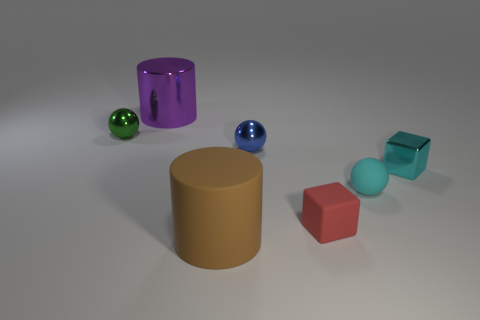How many cylinders are purple metal objects or large objects?
Provide a succinct answer. 2. There is a small rubber thing behind the tiny red rubber cube that is on the right side of the big cylinder that is in front of the rubber block; what is its shape?
Give a very brief answer. Sphere. The object that is the same color as the shiny cube is what shape?
Make the answer very short. Sphere. How many metal cylinders are the same size as the matte sphere?
Ensure brevity in your answer.  0. Is there a cyan rubber ball behind the cylinder that is in front of the big purple metallic thing?
Your answer should be compact. Yes. How many things are either blue metal things or small rubber things?
Give a very brief answer. 3. What is the color of the big thing that is behind the tiny red thing in front of the large object behind the cyan ball?
Your response must be concise. Purple. Is there anything else of the same color as the tiny shiny cube?
Make the answer very short. Yes. Is the size of the green metal ball the same as the brown cylinder?
Provide a succinct answer. No. What number of things are cylinders that are behind the big brown matte thing or spheres that are on the left side of the big brown thing?
Your answer should be very brief. 2. 